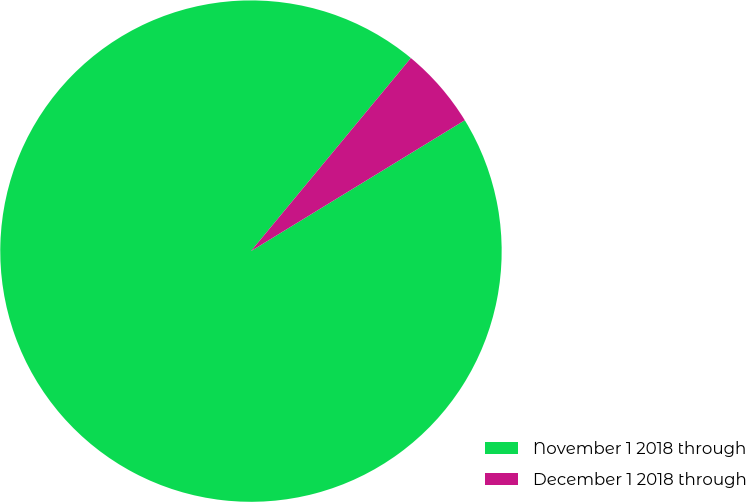Convert chart. <chart><loc_0><loc_0><loc_500><loc_500><pie_chart><fcel>November 1 2018 through<fcel>December 1 2018 through<nl><fcel>94.75%<fcel>5.25%<nl></chart> 